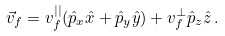Convert formula to latex. <formula><loc_0><loc_0><loc_500><loc_500>\vec { v } _ { f } = v _ { f } ^ { | | } ( \hat { p } _ { x } \hat { x } + \hat { p } _ { y } \hat { y } ) + v _ { f } ^ { \perp } \hat { p } _ { z } \hat { z } \, .</formula> 